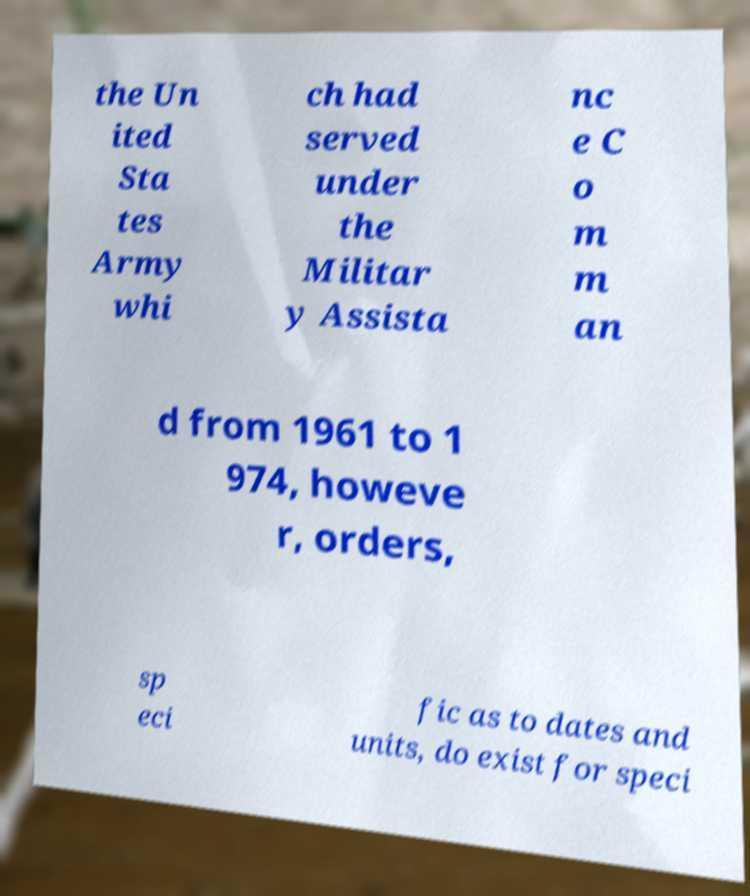There's text embedded in this image that I need extracted. Can you transcribe it verbatim? the Un ited Sta tes Army whi ch had served under the Militar y Assista nc e C o m m an d from 1961 to 1 974, howeve r, orders, sp eci fic as to dates and units, do exist for speci 